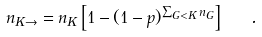<formula> <loc_0><loc_0><loc_500><loc_500>n _ { K \rightarrow } = { n _ { K } } \left [ 1 - ( 1 - p ) ^ { \sum _ { G < K } { n _ { G } } } \right ] \ \ .</formula> 